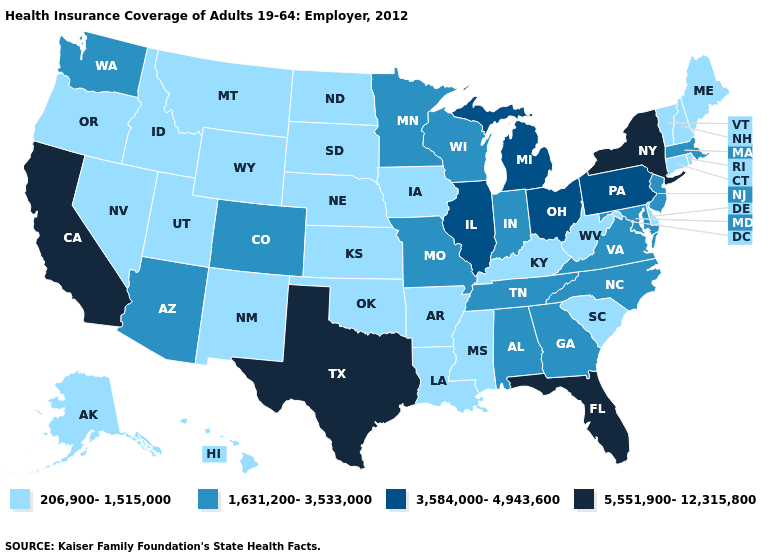Name the states that have a value in the range 5,551,900-12,315,800?
Write a very short answer. California, Florida, New York, Texas. What is the highest value in the Northeast ?
Write a very short answer. 5,551,900-12,315,800. Is the legend a continuous bar?
Give a very brief answer. No. What is the value of Rhode Island?
Give a very brief answer. 206,900-1,515,000. Does the map have missing data?
Give a very brief answer. No. What is the value of Wyoming?
Be succinct. 206,900-1,515,000. What is the lowest value in the USA?
Give a very brief answer. 206,900-1,515,000. What is the highest value in the USA?
Short answer required. 5,551,900-12,315,800. Name the states that have a value in the range 3,584,000-4,943,600?
Short answer required. Illinois, Michigan, Ohio, Pennsylvania. Name the states that have a value in the range 206,900-1,515,000?
Give a very brief answer. Alaska, Arkansas, Connecticut, Delaware, Hawaii, Idaho, Iowa, Kansas, Kentucky, Louisiana, Maine, Mississippi, Montana, Nebraska, Nevada, New Hampshire, New Mexico, North Dakota, Oklahoma, Oregon, Rhode Island, South Carolina, South Dakota, Utah, Vermont, West Virginia, Wyoming. What is the lowest value in the USA?
Be succinct. 206,900-1,515,000. Which states have the lowest value in the USA?
Concise answer only. Alaska, Arkansas, Connecticut, Delaware, Hawaii, Idaho, Iowa, Kansas, Kentucky, Louisiana, Maine, Mississippi, Montana, Nebraska, Nevada, New Hampshire, New Mexico, North Dakota, Oklahoma, Oregon, Rhode Island, South Carolina, South Dakota, Utah, Vermont, West Virginia, Wyoming. Does the first symbol in the legend represent the smallest category?
Write a very short answer. Yes. Is the legend a continuous bar?
Concise answer only. No. What is the value of Oregon?
Short answer required. 206,900-1,515,000. 